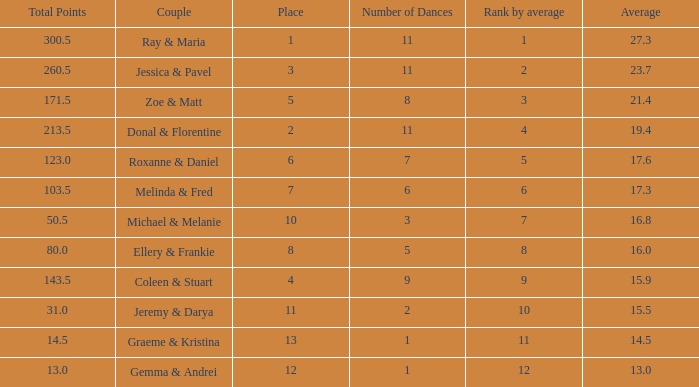If your rank by average is 9, what is the name of the couple? Coleen & Stuart. 